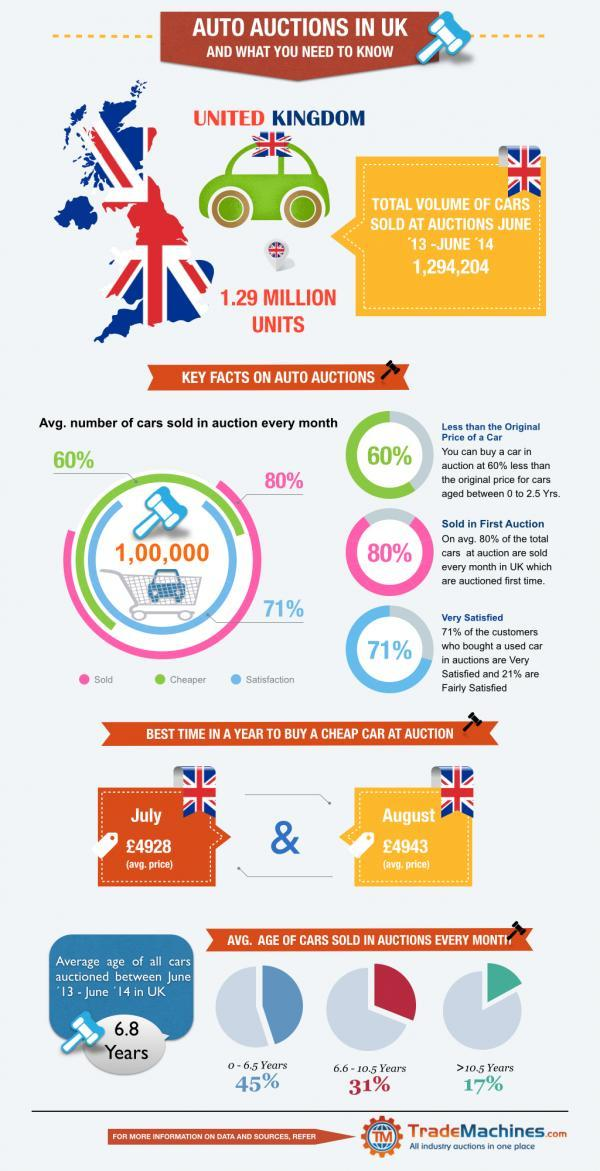Cars in which ages are least preferred?
Answer the question with a short phrase. >10.5 Years 